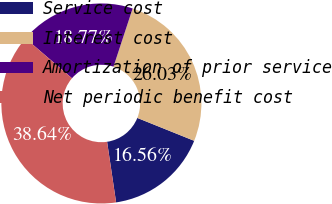<chart> <loc_0><loc_0><loc_500><loc_500><pie_chart><fcel>Service cost<fcel>Interest cost<fcel>Amortization of prior service<fcel>Net periodic benefit cost<nl><fcel>16.56%<fcel>26.03%<fcel>18.77%<fcel>38.64%<nl></chart> 